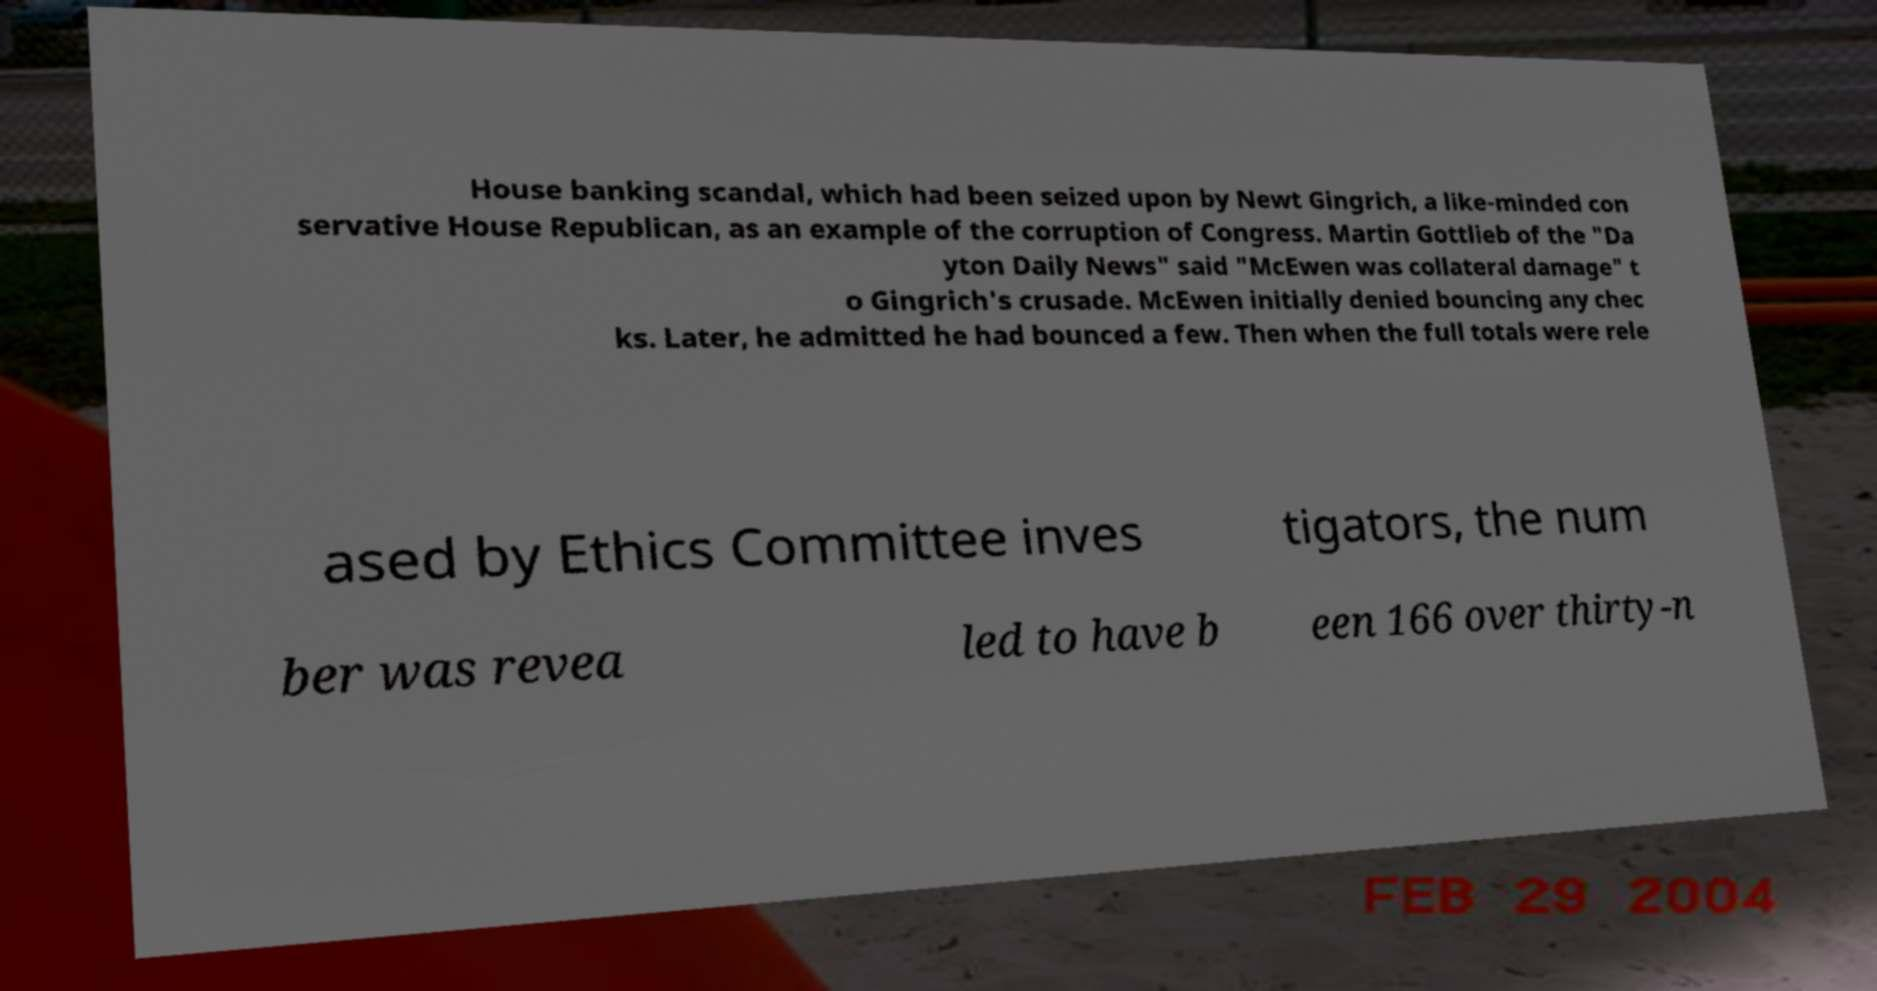Could you extract and type out the text from this image? House banking scandal, which had been seized upon by Newt Gingrich, a like-minded con servative House Republican, as an example of the corruption of Congress. Martin Gottlieb of the "Da yton Daily News" said "McEwen was collateral damage" t o Gingrich's crusade. McEwen initially denied bouncing any chec ks. Later, he admitted he had bounced a few. Then when the full totals were rele ased by Ethics Committee inves tigators, the num ber was revea led to have b een 166 over thirty-n 